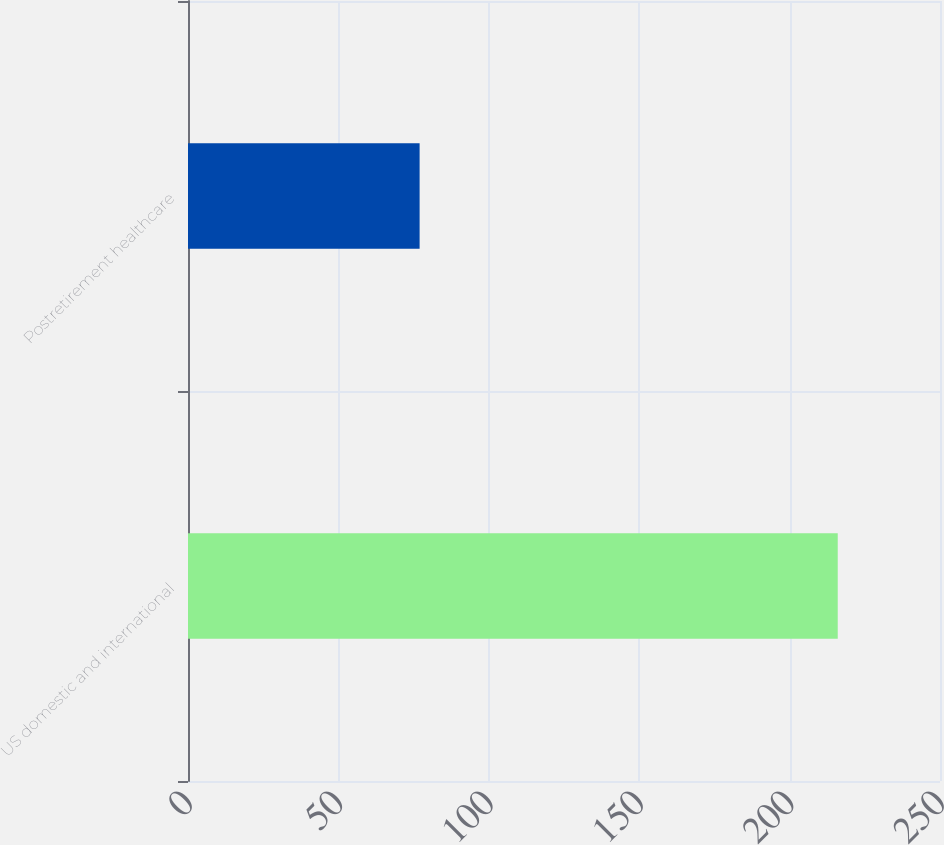<chart> <loc_0><loc_0><loc_500><loc_500><bar_chart><fcel>US domestic and international<fcel>Postretirement healthcare<nl><fcel>216<fcel>77<nl></chart> 